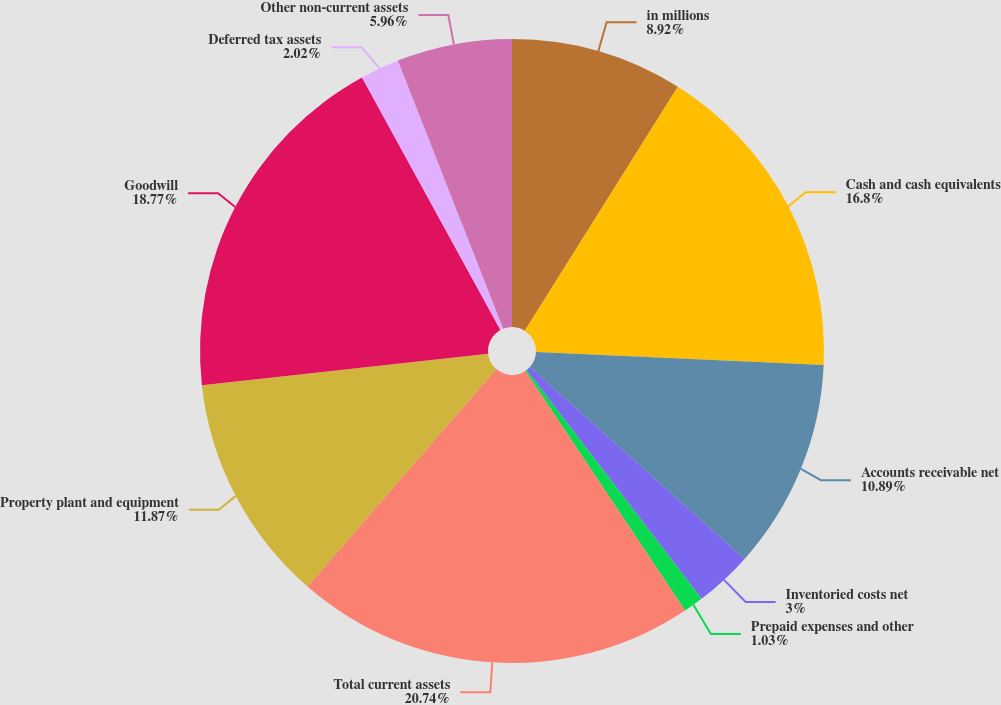<chart> <loc_0><loc_0><loc_500><loc_500><pie_chart><fcel>in millions<fcel>Cash and cash equivalents<fcel>Accounts receivable net<fcel>Inventoried costs net<fcel>Prepaid expenses and other<fcel>Total current assets<fcel>Property plant and equipment<fcel>Goodwill<fcel>Deferred tax assets<fcel>Other non-current assets<nl><fcel>8.92%<fcel>16.8%<fcel>10.89%<fcel>3.0%<fcel>1.03%<fcel>20.74%<fcel>11.87%<fcel>18.77%<fcel>2.02%<fcel>5.96%<nl></chart> 